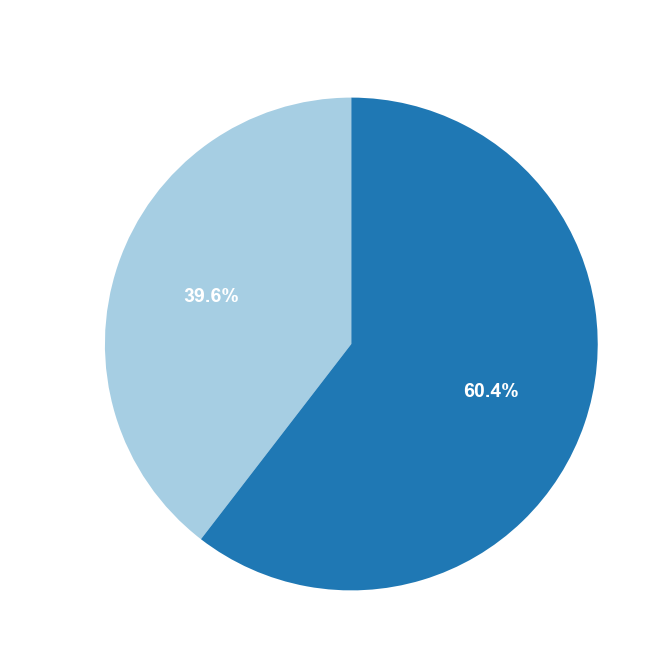What percentage of the customer base comes from urban areas? From the pie chart, identify the slice representing the urban areas, then read the percentage label directly from it.
Answer: 68.2% What is the difference in customer base percentage between urban and suburban locations? Locate the percentages for both urban and suburban areas on the pie chart. Subtract the suburban percentage from the urban percentage.
Answer: 36.4% How do the suburban customer base percentages compare to the urban customer base percentages? Examine the percentages indicated on the pie chart for both suburban and urban slices to determine which is greater.
Answer: Urban is greater Which location type has the smallest customer base percentage? Identify the slice on the pie chart with the smallest percentage label.
Answer: Suburban What fraction of the customer base is suburban? Identify the percentage of the suburban customer base from the pie chart and convert it to a fraction by dividing by 100. E.g., 31.8% becomes 31.8/100 = 0.318
Answer: 0.318 If the total customer base is 1000, how many customers are in the urban areas? Take the percentage of customers in urban areas from the pie chart (68.2%) and multiply it by the total number of customers (1000). E.g., 68.2% of 1000 = 0.682 * 1000
Answer: 682 